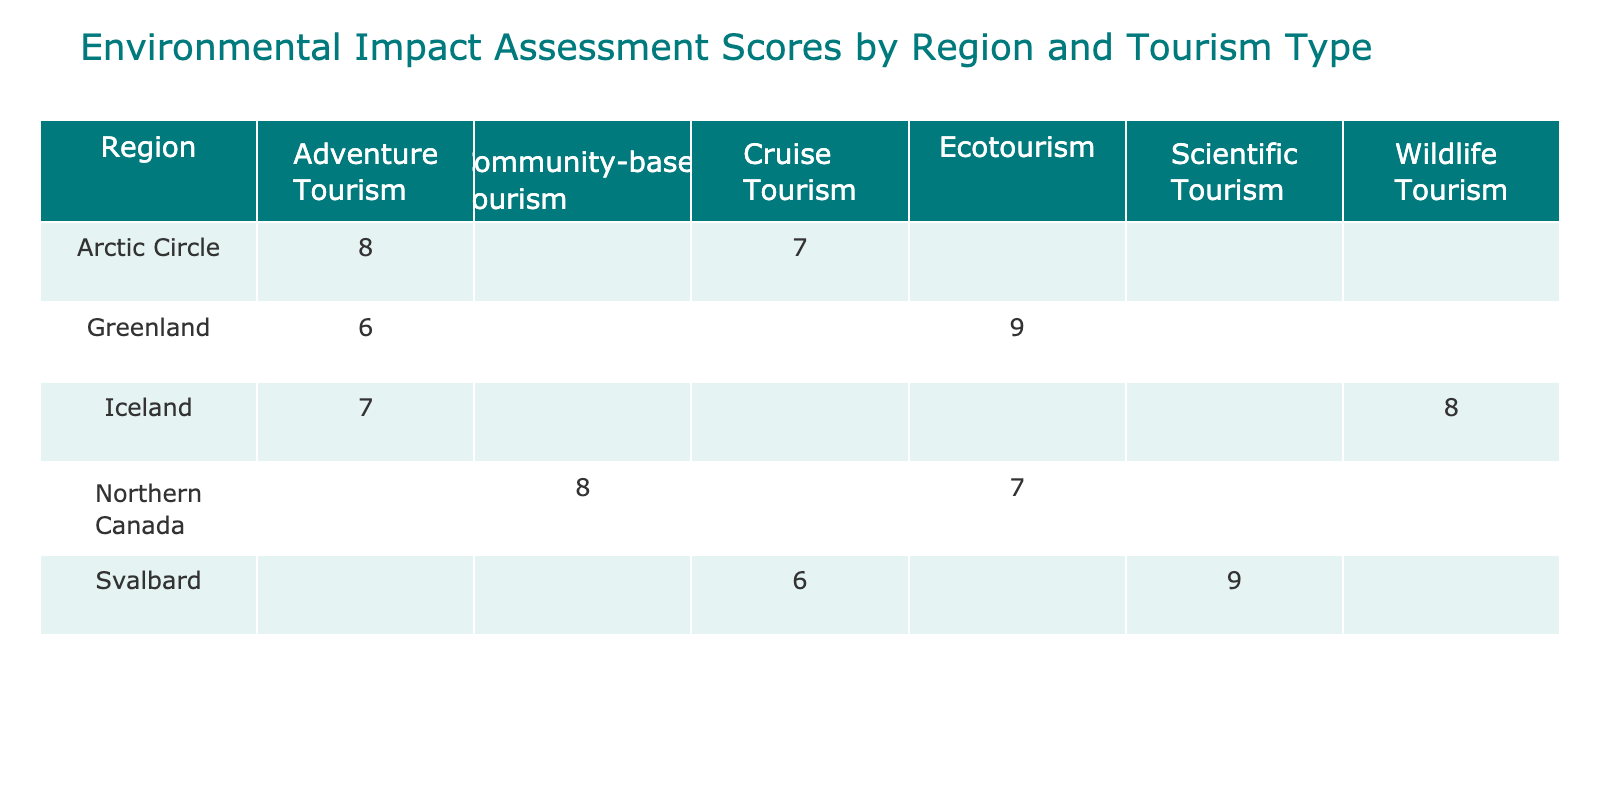What is the Environmental Impact Assessment score for Adventure Tourism in the Arctic Circle? The table displays a score of 8 for Adventure Tourism specifically in the Arctic Circle.
Answer: 8 What region has the highest Environmental Impact Assessment score for Ecotourism? According to the table, Greenland has the highest score of 9 for Ecotourism.
Answer: Greenland Is the Environmental Impact Assessment score for Cruise Tourism in Svalbard higher than that in the Arctic Circle? The score for Cruise Tourism in Svalbard is 6, while in the Arctic Circle it is 7. Thus, Svalbard's score is not higher.
Answer: No What is the average Environmental Impact Assessment score for all types of tourism in Greenland? For Greenland, the scores are 9 (Ecotourism) and 6 (Adventure Tourism). The average is calculated as (9 + 6) / 2 = 7.5.
Answer: 7.5 Which type of tourism has the lowest Environmental Impact Assessment score overall? By examining the scores, Adventure Tourism in Greenland has the lowest score of 6 when compared across all regions and tourism types.
Answer: Adventure Tourism in Greenland What is the difference between the highest and lowest scores for Environmental Impact Assessment in the Arctic Circle? The highest score in the Arctic Circle is 8 (Adventure Tourism), and the lowest is 7 (Cruise Tourism). The difference is 8 - 7 = 1.
Answer: 1 Does any region have a score of 10 for any type of tourism? Upon reviewing the table, none of the regions have a score of 10 listed for any type of tourism.
Answer: No What is the total Environmental Impact Assessment score for Community-based Tourism in Northern Canada? The table indicates that there is only one value for Community-based Tourism in Northern Canada, which is 8. Therefore, the total score is 8.
Answer: 8 What is the sum of the Environmental Impact Assessment scores for all types of tourism in Svalbard? In Svalbard, the scores are 9 (Scientific Tourism) and 6 (Cruise Tourism). The sum of these scores is 9 + 6 = 15.
Answer: 15 